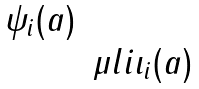Convert formula to latex. <formula><loc_0><loc_0><loc_500><loc_500>\begin{matrix} \psi _ { i } ( a ) & \\ & \mu l { i } \iota _ { i } ( a ) \end{matrix}</formula> 